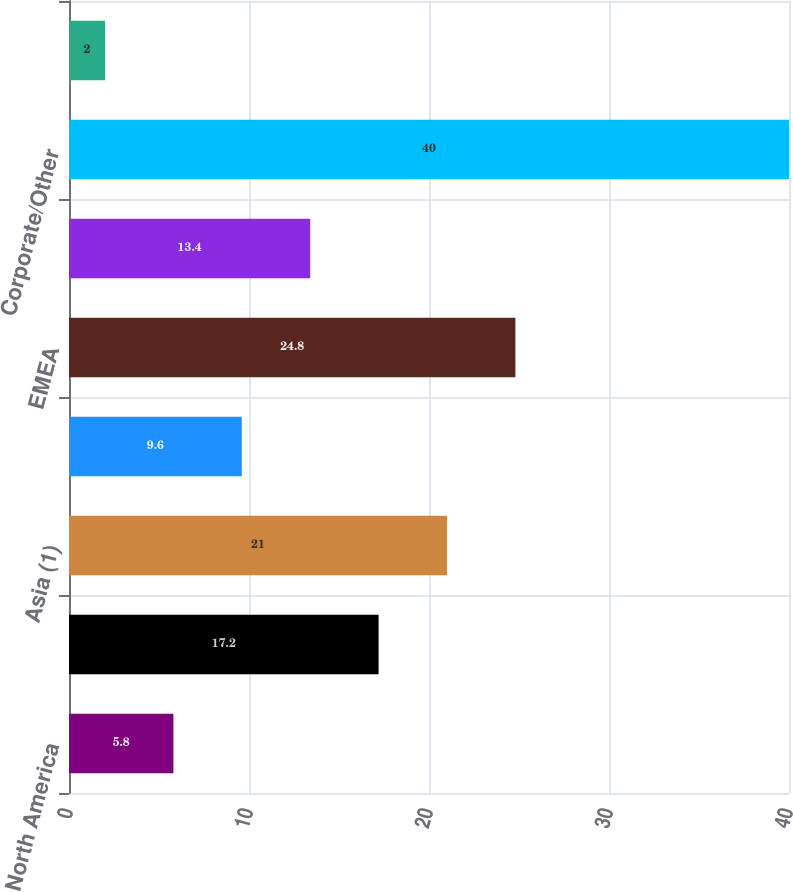Convert chart. <chart><loc_0><loc_0><loc_500><loc_500><bar_chart><fcel>North America<fcel>Latin America<fcel>Asia (1)<fcel>Total<fcel>EMEA<fcel>Asia<fcel>Corporate/Other<fcel>Total Citigroup net revenues<nl><fcel>5.8<fcel>17.2<fcel>21<fcel>9.6<fcel>24.8<fcel>13.4<fcel>40<fcel>2<nl></chart> 